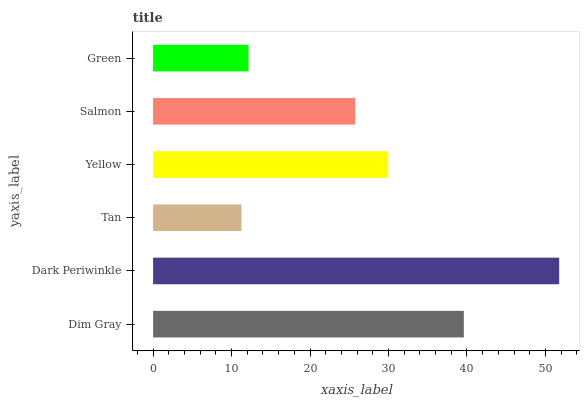Is Tan the minimum?
Answer yes or no. Yes. Is Dark Periwinkle the maximum?
Answer yes or no. Yes. Is Dark Periwinkle the minimum?
Answer yes or no. No. Is Tan the maximum?
Answer yes or no. No. Is Dark Periwinkle greater than Tan?
Answer yes or no. Yes. Is Tan less than Dark Periwinkle?
Answer yes or no. Yes. Is Tan greater than Dark Periwinkle?
Answer yes or no. No. Is Dark Periwinkle less than Tan?
Answer yes or no. No. Is Yellow the high median?
Answer yes or no. Yes. Is Salmon the low median?
Answer yes or no. Yes. Is Dark Periwinkle the high median?
Answer yes or no. No. Is Green the low median?
Answer yes or no. No. 